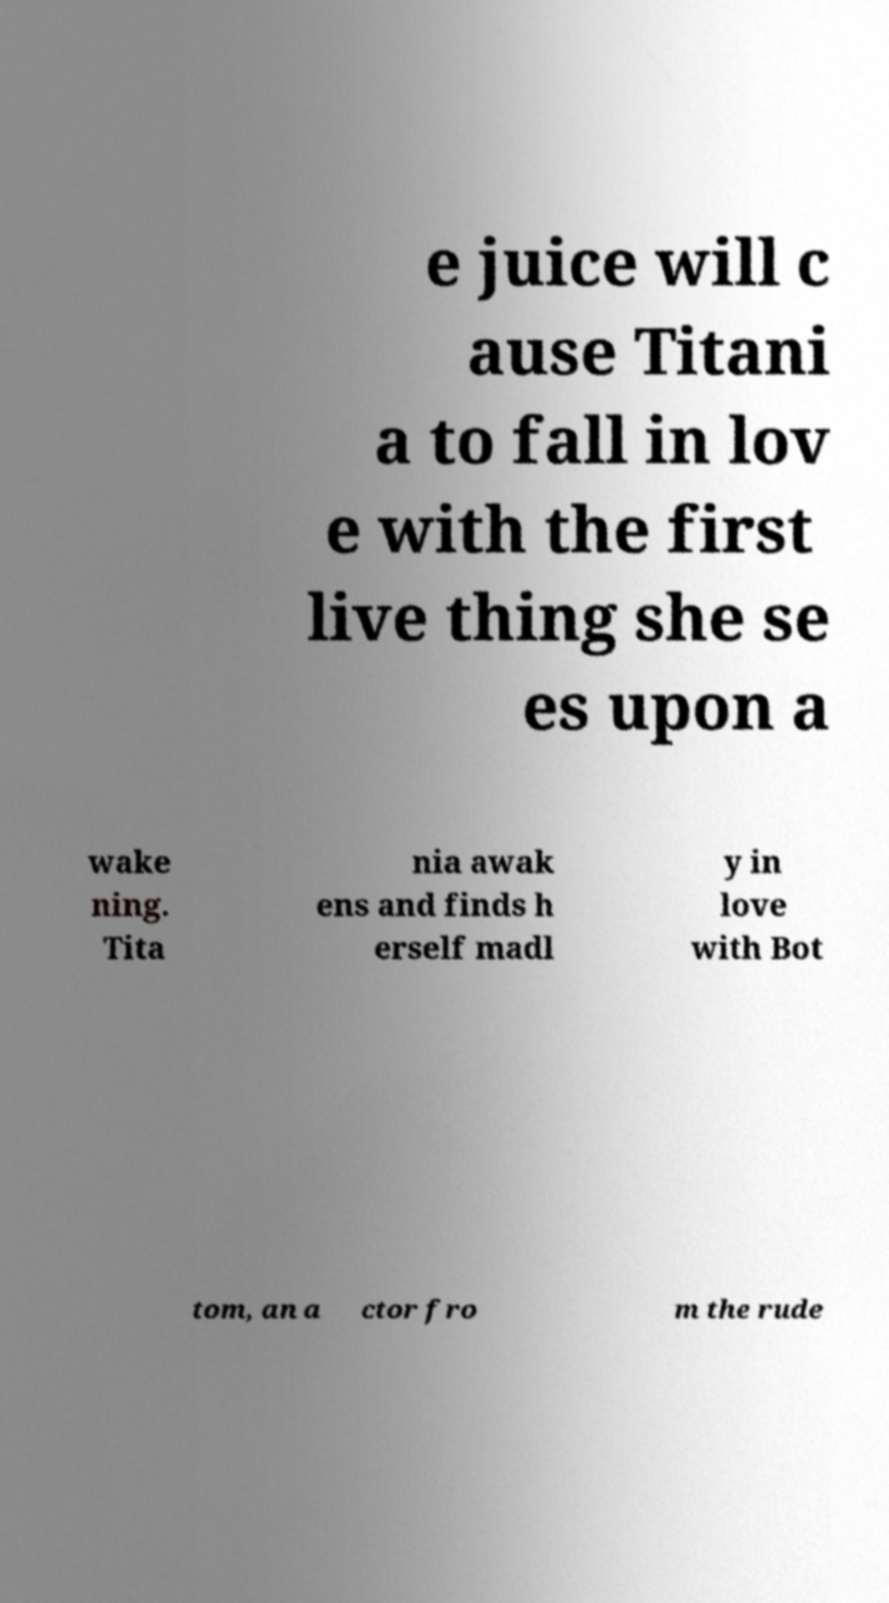For documentation purposes, I need the text within this image transcribed. Could you provide that? e juice will c ause Titani a to fall in lov e with the first live thing she se es upon a wake ning. Tita nia awak ens and finds h erself madl y in love with Bot tom, an a ctor fro m the rude 